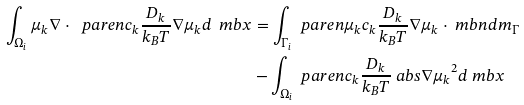<formula> <loc_0><loc_0><loc_500><loc_500>\int _ { \Omega _ { i } } \mu _ { k } \nabla \cdot \ p a r e n { c _ { k } \frac { D _ { k } } { k _ { B } T } \nabla \mu _ { k } } d \ m b { x } & = \int _ { \Gamma _ { i } } \ p a r e n { \mu _ { k } { c _ { k } \frac { D _ { k } } { k _ { B } T } \nabla \mu _ { k } } \cdot \ m b { n } } d m _ { \Gamma } \\ & - \int _ { \Omega _ { i } } \ p a r e n { c _ { k } \frac { D _ { k } } { k _ { B } T } \ a b s { \nabla \mu _ { k } } ^ { 2 } } d \ m b { x }</formula> 